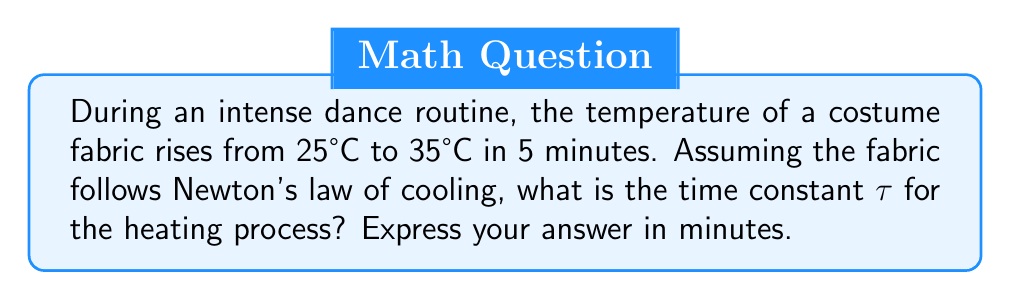Can you answer this question? To solve this problem, we'll use Newton's law of cooling (or in this case, heating) and the concept of time constant. Let's break it down step-by-step:

1) Newton's law of cooling/heating is given by:

   $$T(t) = T_s + (T_0 - T_s)e^{-t/τ}$$

   Where:
   - $T(t)$ is the temperature at time $t$
   - $T_s$ is the surrounding temperature (in this case, the final temperature)
   - $T_0$ is the initial temperature
   - $τ$ is the time constant

2) We know:
   - Initial temperature $T_0 = 25°C$
   - Final temperature $T_s = 35°C$
   - Time $t = 5$ minutes
   - Temperature at $t=5$ minutes, $T(5) = 35°C$

3) Substituting these values into the equation:

   $$35 = 35 + (25 - 35)e^{-5/τ}$$

4) Simplifying:

   $$0 = -10e^{-5/τ}$$

5) Taking the natural log of both sides:

   $$\ln(0) = \ln(-10) - 5/τ$$

6) Since $\ln(0)$ is undefined, we can't solve this exactly. However, we can approximate that the temperature has reached 99% of its final value after 5 minutes. In that case:

   $$0.99 = 1 - e^{-5/τ}$$

7) Solving for τ:

   $$e^{-5/τ} = 0.01$$
   $$-5/τ = \ln(0.01)$$
   $$τ = -5/\ln(0.01) ≈ 1.08$$

Thus, the time constant τ is approximately 1.08 minutes.
Answer: 1.08 minutes 